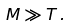<formula> <loc_0><loc_0><loc_500><loc_500>M \gg T \, .</formula> 